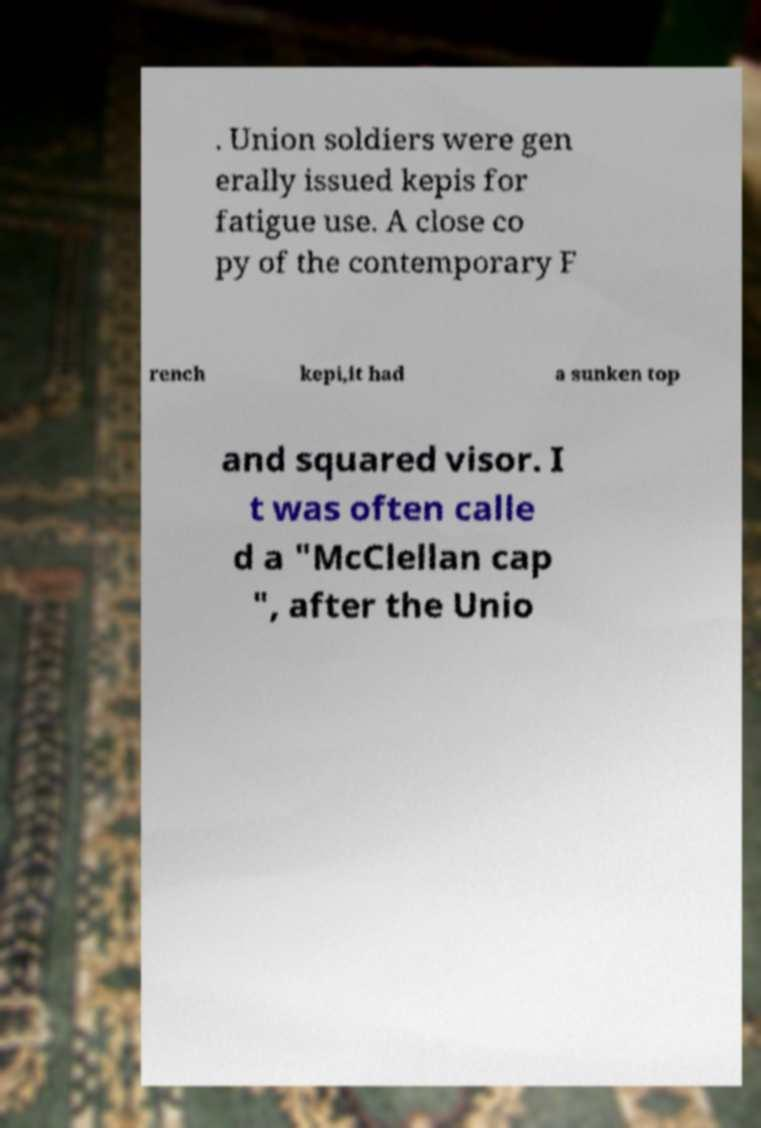Please identify and transcribe the text found in this image. . Union soldiers were gen erally issued kepis for fatigue use. A close co py of the contemporary F rench kepi,it had a sunken top and squared visor. I t was often calle d a "McClellan cap ", after the Unio 